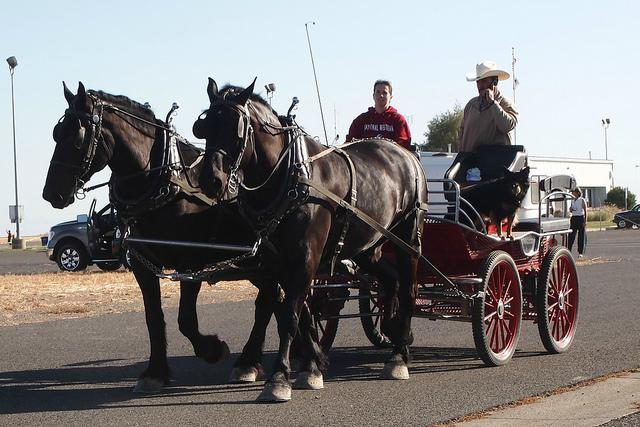What are the horses doing? Please explain your reasoning. pulling cart. The horses are on the road pulling the trailer with people on it. 